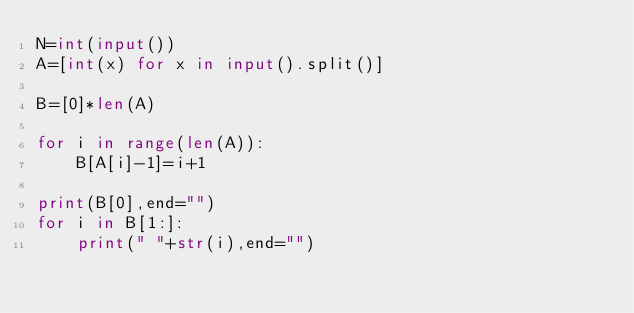Convert code to text. <code><loc_0><loc_0><loc_500><loc_500><_Python_>N=int(input())
A=[int(x) for x in input().split()]

B=[0]*len(A)

for i in range(len(A)):
    B[A[i]-1]=i+1

print(B[0],end="")
for i in B[1:]:
    print(" "+str(i),end="")</code> 